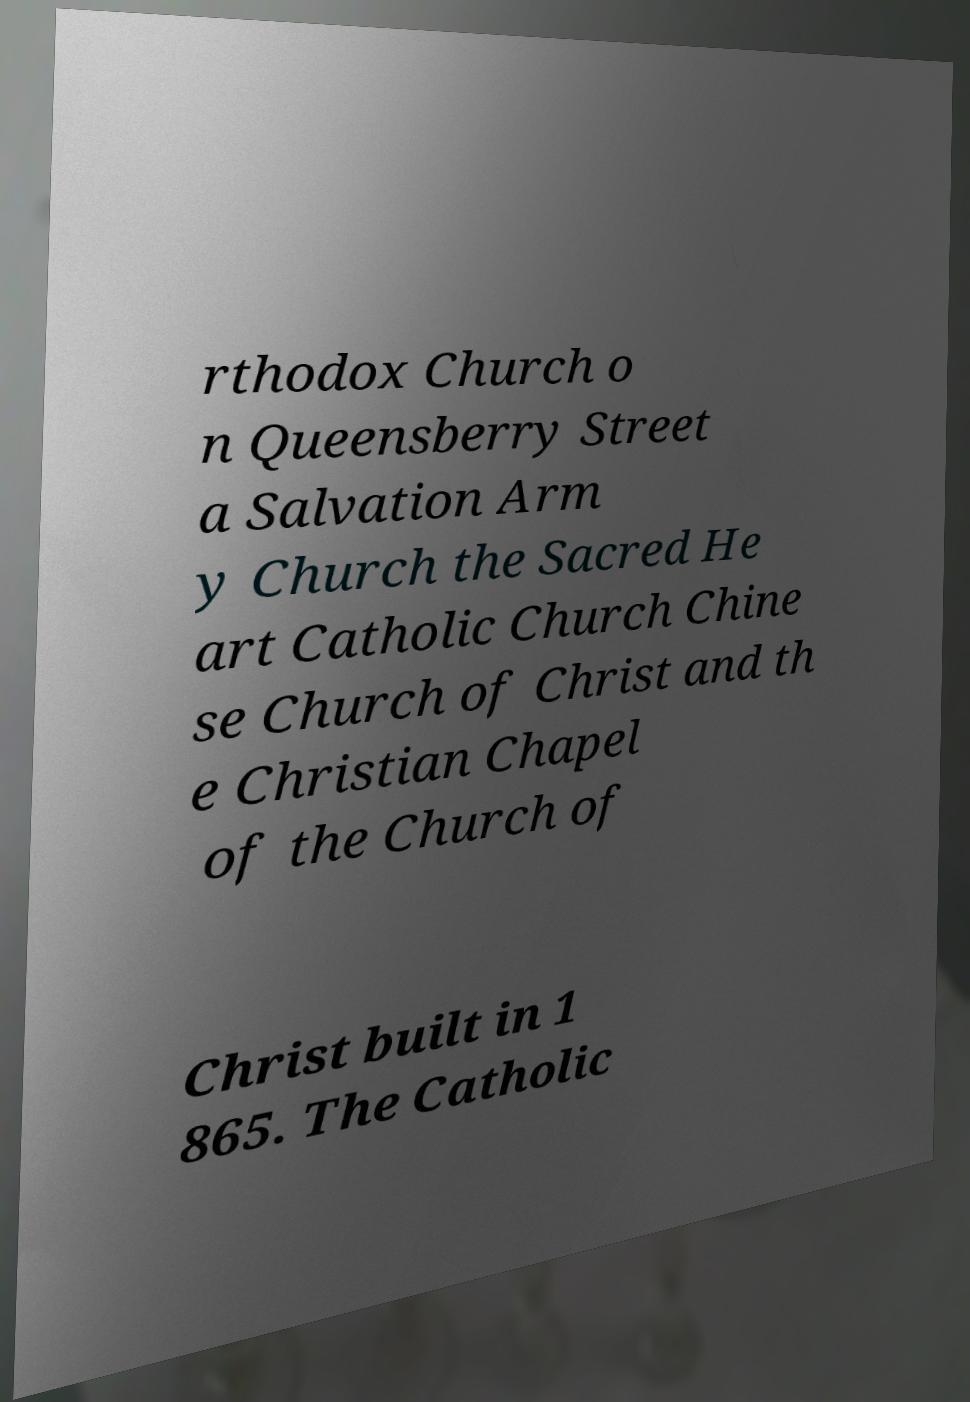What messages or text are displayed in this image? I need them in a readable, typed format. rthodox Church o n Queensberry Street a Salvation Arm y Church the Sacred He art Catholic Church Chine se Church of Christ and th e Christian Chapel of the Church of Christ built in 1 865. The Catholic 